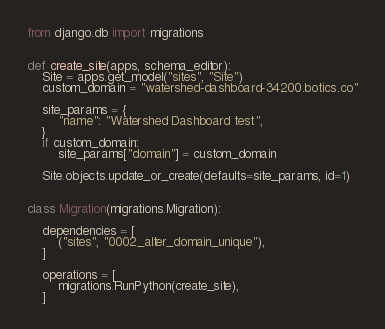<code> <loc_0><loc_0><loc_500><loc_500><_Python_>from django.db import migrations


def create_site(apps, schema_editor):
    Site = apps.get_model("sites", "Site")
    custom_domain = "watershed-dashboard-34200.botics.co"

    site_params = {
        "name": "Watershed Dashboard test",
    }
    if custom_domain:
        site_params["domain"] = custom_domain

    Site.objects.update_or_create(defaults=site_params, id=1)


class Migration(migrations.Migration):

    dependencies = [
        ("sites", "0002_alter_domain_unique"),
    ]

    operations = [
        migrations.RunPython(create_site),
    ]
</code> 